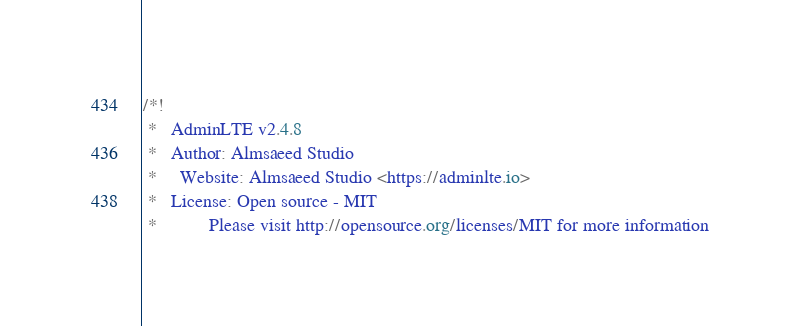Convert code to text. <code><loc_0><loc_0><loc_500><loc_500><_CSS_>/*!
 *   AdminLTE v2.4.8
 *   Author: Almsaeed Studio
 *	 Website: Almsaeed Studio <https://adminlte.io>
 *   License: Open source - MIT
 *           Please visit http://opensource.org/licenses/MIT for more information</code> 